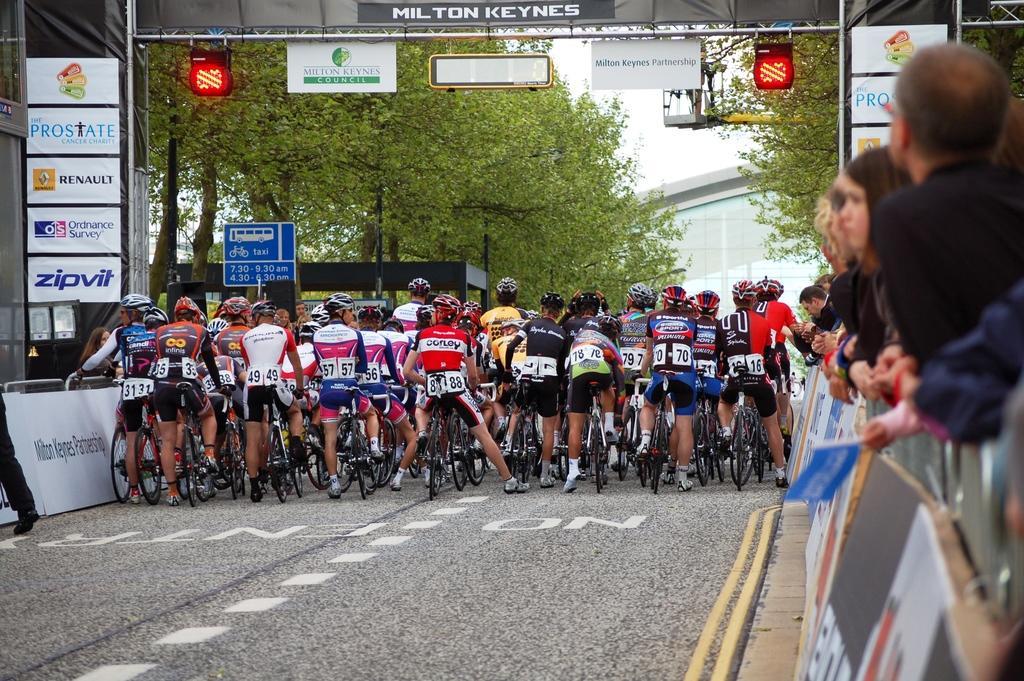Can you describe this image briefly? In the foreground I can see a crowd is standing on the road, fence and a group of people are riding bicycles on the road. In the background I can see trees, boards, arch, light poles, buildings and the sky. This image is taken may be during a day. 